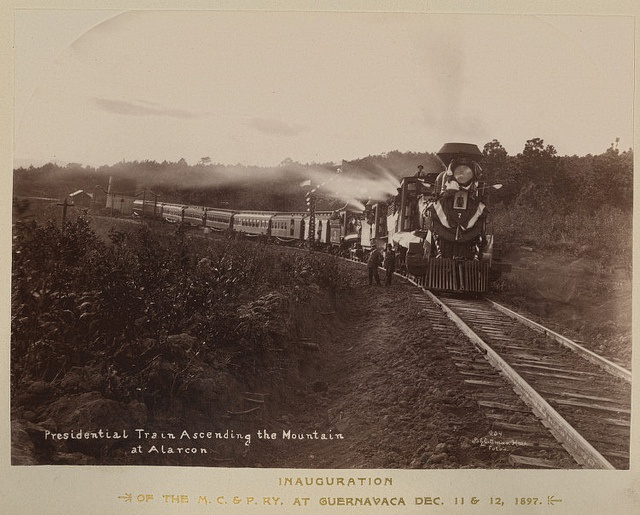Describe the objects in this image and their specific colors. I can see train in tan, black, gray, and maroon tones, people in tan, black, gray, and maroon tones, people in tan, black, gray, and darkgray tones, and people in tan, gray, black, and maroon tones in this image. 